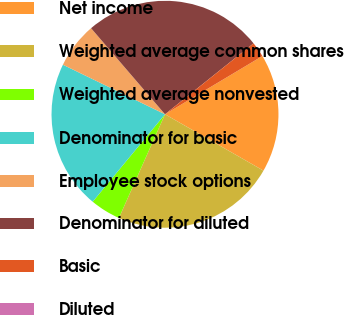Convert chart to OTSL. <chart><loc_0><loc_0><loc_500><loc_500><pie_chart><fcel>Net income<fcel>Weighted average common shares<fcel>Weighted average nonvested<fcel>Denominator for basic<fcel>Employee stock options<fcel>Denominator for diluted<fcel>Basic<fcel>Diluted<nl><fcel>16.85%<fcel>23.38%<fcel>4.34%<fcel>21.2%<fcel>6.51%<fcel>25.55%<fcel>2.17%<fcel>0.0%<nl></chart> 